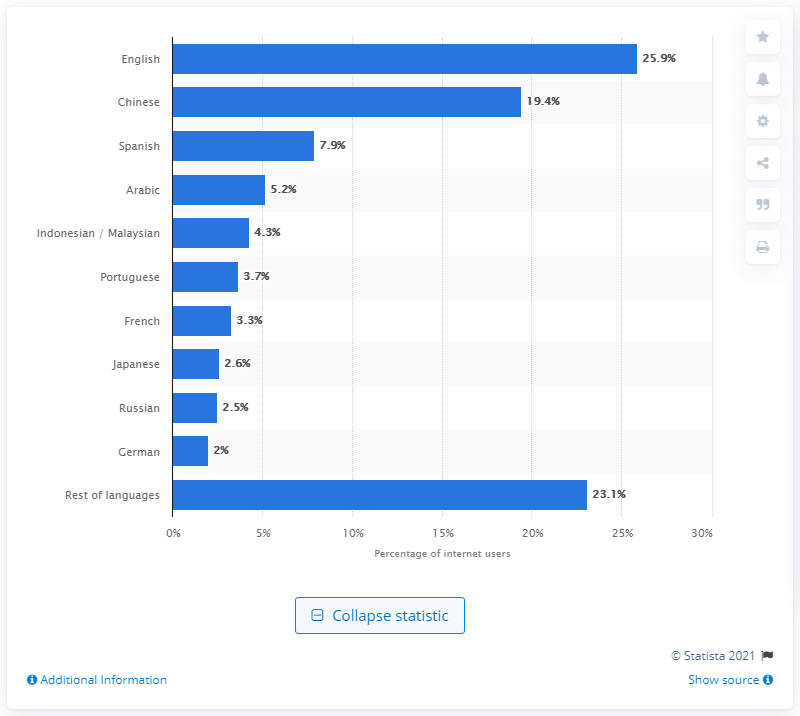Specify some key components in this picture. As of January 2020, approximately 25.9% of internet users spoke English. As of January 2020, the most popular language online was English. 